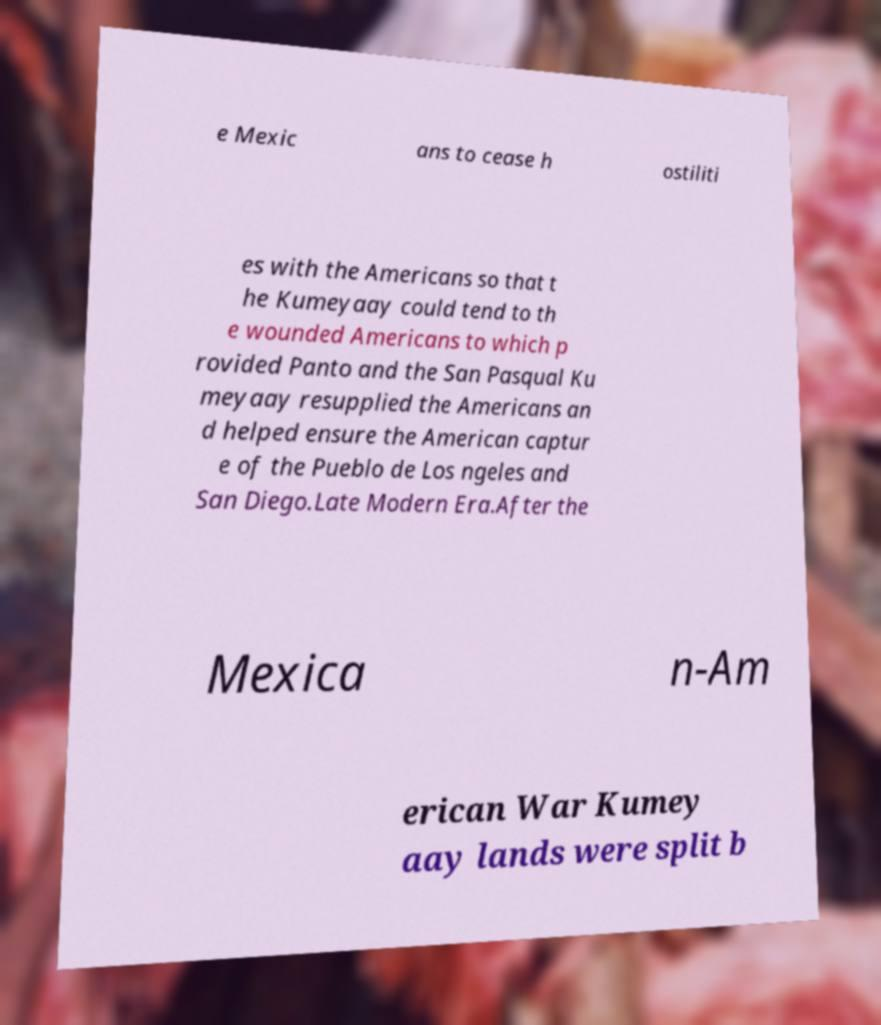Could you assist in decoding the text presented in this image and type it out clearly? e Mexic ans to cease h ostiliti es with the Americans so that t he Kumeyaay could tend to th e wounded Americans to which p rovided Panto and the San Pasqual Ku meyaay resupplied the Americans an d helped ensure the American captur e of the Pueblo de Los ngeles and San Diego.Late Modern Era.After the Mexica n-Am erican War Kumey aay lands were split b 